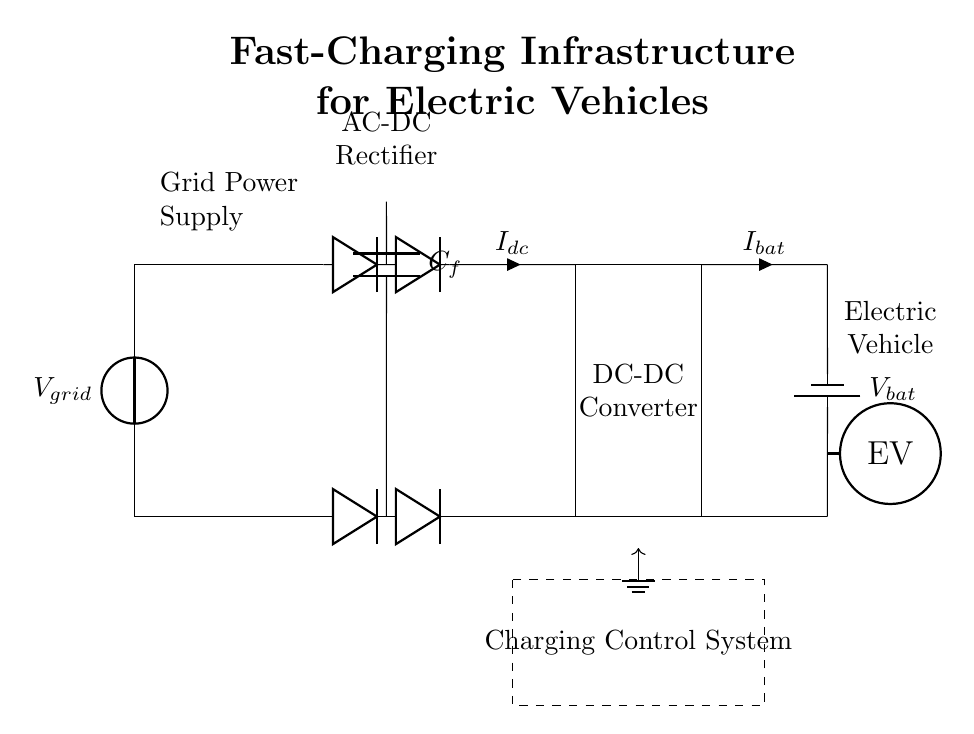What is the power source in this circuit? The power source is indicated at the beginning of the circuit diagram as a voltage source symbol, labeled as V-grid.
Answer: V-grid What type of transformer is used? The circuit shows a transformer that is connected directly after the power source, which is necessary for voltage adjustment in the circuit.
Answer: Transformer What does the capacitor C-f do in this circuit? The capacitor C-f is connected after the rectifier and helps smooth the output from the AC to DC conversion, providing stability in the voltage supply to the DC-DC converter.
Answer: Smooths output What is the purpose of the DC-DC converter? The DC-DC converter is designed to regulate and convert the DC voltage for optimum charging of the battery, indicated by its labeled box in the diagram.
Answer: Voltage regulation What current is denoted entering the battery? The current entering the battery is indicated by the labeled current I-bat, which flows from the DC-DC converter to the battery.
Answer: I-bat How does the charging control system interact with the circuit? The charging control system, depicted by a dashed rectangle, coordinates the charging operation and safety mechanisms, ensuring the battery and EV are charged efficiently without overloading.
Answer: Coordinates charging What does the EV symbol represent? The EV symbol represents the electric vehicle that is being charged in this circuit. It shows the final destination for the electrical energy provided by the circuit components.
Answer: Electric vehicle 